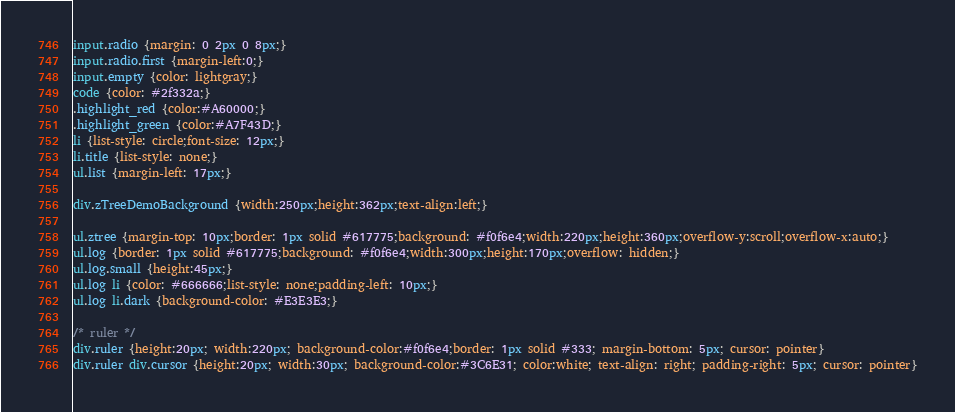Convert code to text. <code><loc_0><loc_0><loc_500><loc_500><_CSS_>input.radio {margin: 0 2px 0 8px;}
input.radio.first {margin-left:0;}
input.empty {color: lightgray;}
code {color: #2f332a;}
.highlight_red {color:#A60000;}
.highlight_green {color:#A7F43D;}
li {list-style: circle;font-size: 12px;}
li.title {list-style: none;}
ul.list {margin-left: 17px;}

div.zTreeDemoBackground {width:250px;height:362px;text-align:left;}

ul.ztree {margin-top: 10px;border: 1px solid #617775;background: #f0f6e4;width:220px;height:360px;overflow-y:scroll;overflow-x:auto;}
ul.log {border: 1px solid #617775;background: #f0f6e4;width:300px;height:170px;overflow: hidden;}
ul.log.small {height:45px;}
ul.log li {color: #666666;list-style: none;padding-left: 10px;}
ul.log li.dark {background-color: #E3E3E3;}

/* ruler */
div.ruler {height:20px; width:220px; background-color:#f0f6e4;border: 1px solid #333; margin-bottom: 5px; cursor: pointer}
div.ruler div.cursor {height:20px; width:30px; background-color:#3C6E31; color:white; text-align: right; padding-right: 5px; cursor: pointer}</code> 